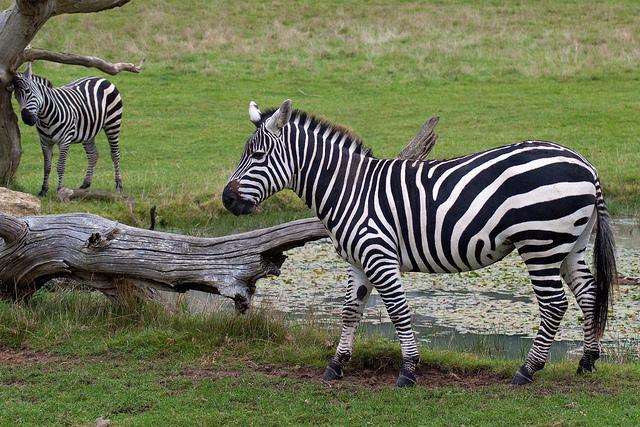What color are the stripes?
Be succinct. Black. What is the zebra on the left doing?
Answer briefly. Scratching. Are these zebras living in the wild?
Write a very short answer. Yes. What animal is this?
Write a very short answer. Zebra. What motion are the Zebra's doing?
Answer briefly. Walking. Is this a baby zebra?
Write a very short answer. No. 